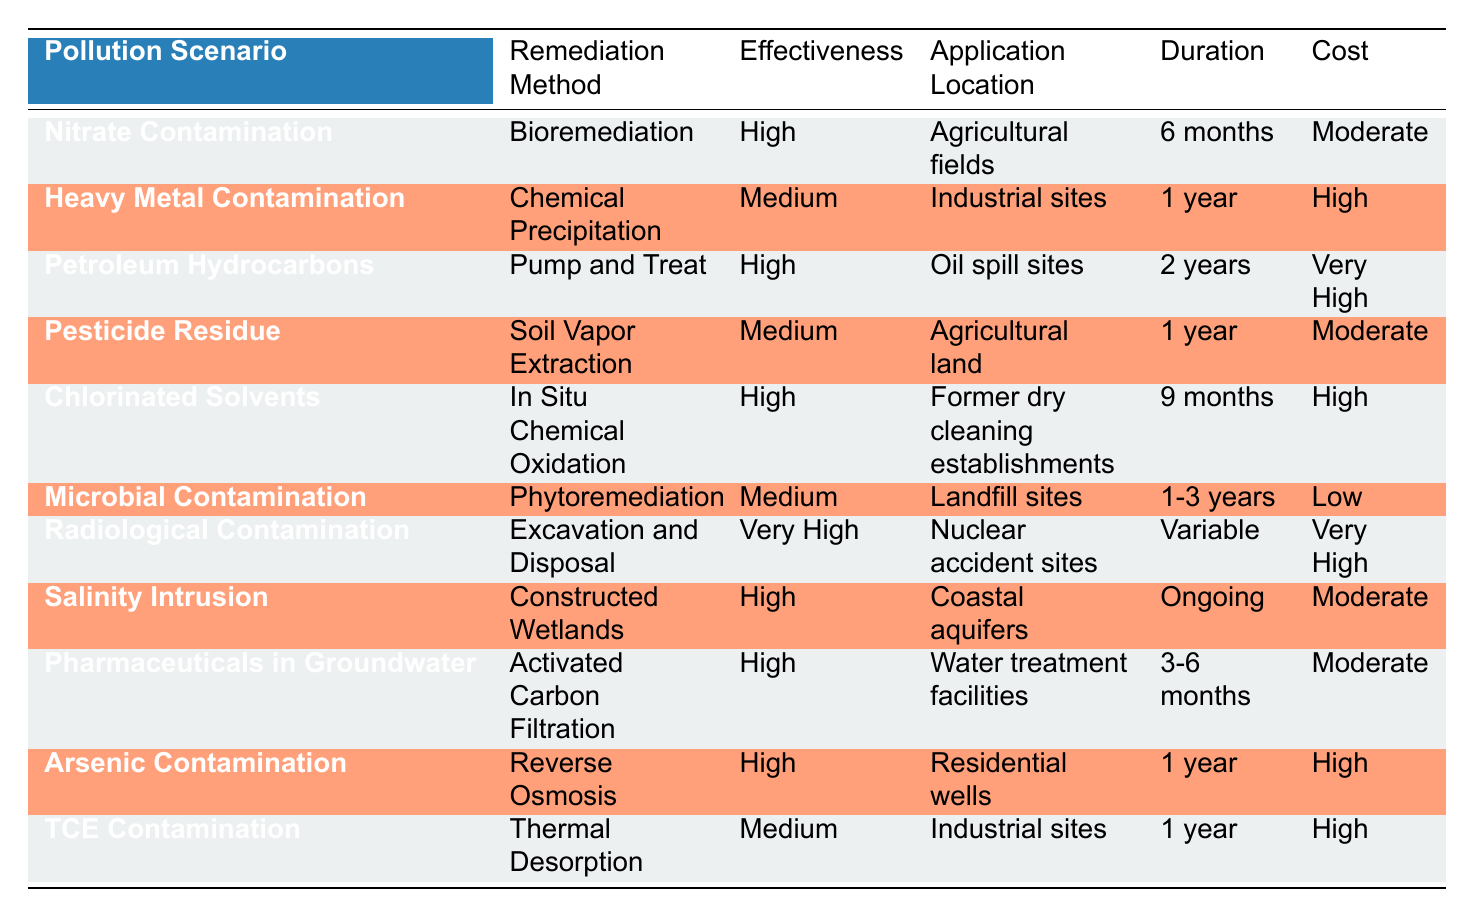What is the remediation method for Nitrate Contamination? The table lists "Bioremediation" as the remediation method under the "Nitrate Contamination" row.
Answer: Bioremediation Which pollution scenario has the highest effectiveness rating? The only pollution scenario with a "Very High" effectiveness rating is "Radiological Contamination."
Answer: Radiological Contamination How many pollution scenarios utilize High effectiveness remediation methods? By counting the rows with "High" in the Effectiveness column, we find five scenarios: Nitrate Contamination, Petroleum Hydrocarbons, Chlorinated Solvents, Salinity Intrusion, and Pharmaceuticals in Groundwater.
Answer: 5 Does the remediation method "Soil Vapor Extraction" have High effectiveness? Referring to the table, "Soil Vapor Extraction" is listed as having "Medium" effectiveness, which answers the question negatively.
Answer: No What is the total duration for remediation methods categorized as High effectiveness? The scenarios with High effectiveness are Nitrate Contamination (6 months), Petroleum Hydrocarbons (2 years), Chlorinated Solvents (9 months), Salinity Intrusion (Ongoing), and Pharmaceuticals in Groundwater (3-6 months). To quantify, we convert all durations to months: 6 + 24 + 9 + (let's consider ongoing as a likely maximum of 24) + (let's average 3-6 months as 4.5) = 67.5 months (or maximum expressed as 83.5 months considering ongoing).
Answer: 67.5 months (or max 83.5 months) Which contamination scenario requires a higher cost, Heavy Metal or Arsenic Contamination? Referring to the "Cost" column, "Heavy Metal Contamination" costs "High," while "Arsenic Contamination" also costs "High." Therefore, they match in cost level, indicating no difference.
Answer: They are equal 